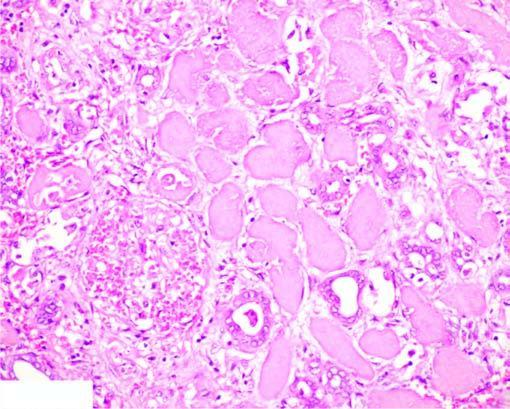does the interface between viable and non-viable area show non-specific chronic inflammation and proliferating vessels?
Answer the question using a single word or phrase. Yes 